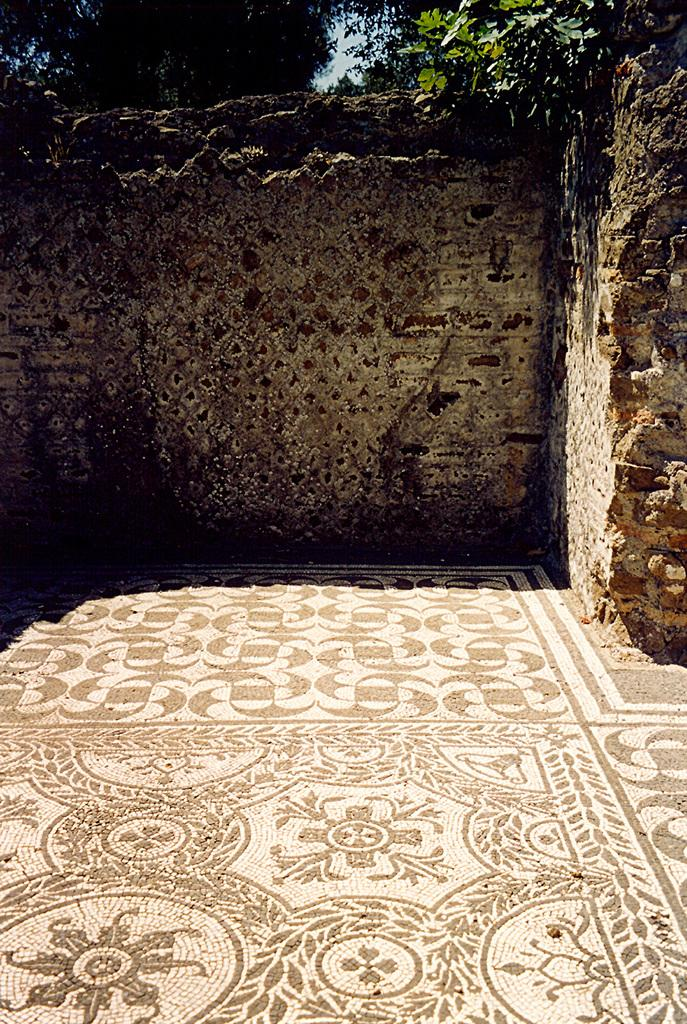What type of structure can be seen in the image? There are walls visible in the image, which suggests a structure of some kind. What part of the natural environment is visible in the image? The sky and trees are visible in the image. What is the ground surface like in the image? The floor is visible in the image. What type of approval is being given in the image? There is no indication of any approval process or decision in the image. What type of dinner is being served in the image? There is no dinner or food visible in the image. What phase of the moon is visible in the image? The moon is not visible in the image; only the sky is visible. 